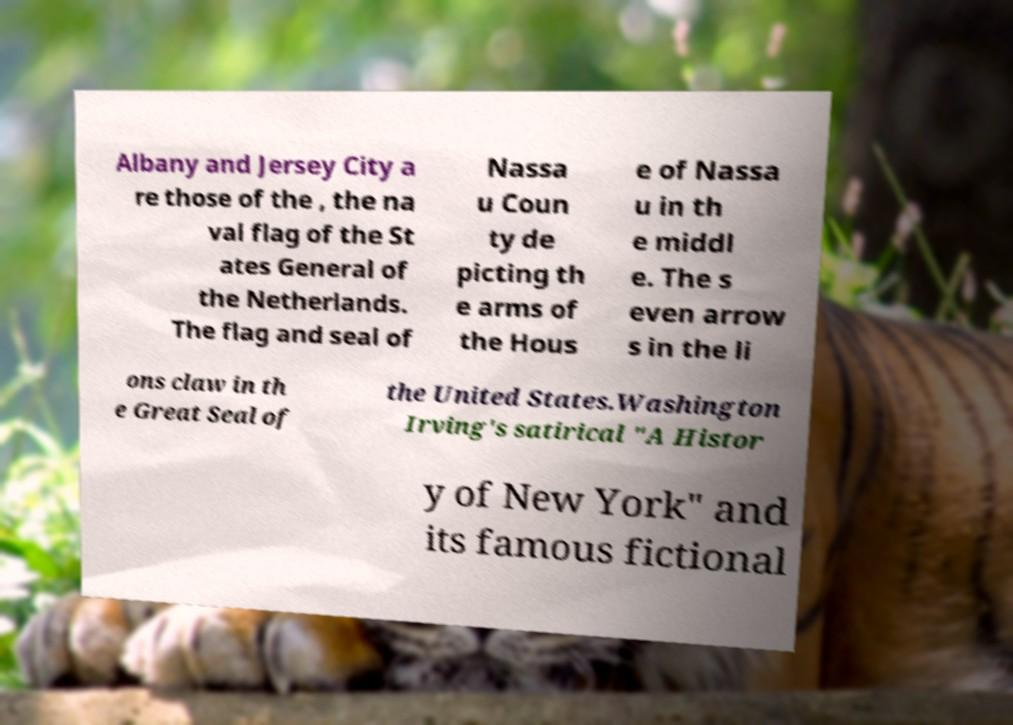There's text embedded in this image that I need extracted. Can you transcribe it verbatim? Albany and Jersey City a re those of the , the na val flag of the St ates General of the Netherlands. The flag and seal of Nassa u Coun ty de picting th e arms of the Hous e of Nassa u in th e middl e. The s even arrow s in the li ons claw in th e Great Seal of the United States.Washington Irving's satirical "A Histor y of New York" and its famous fictional 